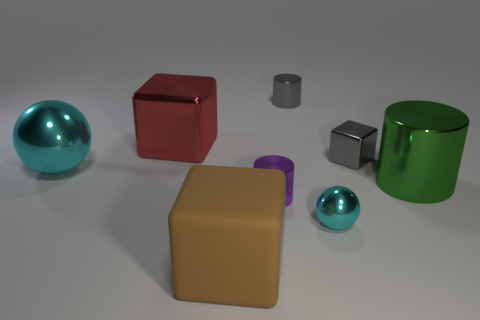Describe the textures visible on the surfaces of these objects. The objects display a variety of surface textures. The spheres and two of the cubes have a highly reflective, smooth surface that suggests a polished metallic or plastic material. The cuboid and the cylinder show a more matte finish, indicating a possible non-metallic nature, such as ceramic or stone. The truncated cone exhibits a semi-gloss texture, differentiating it slightly from the other objects as well. 